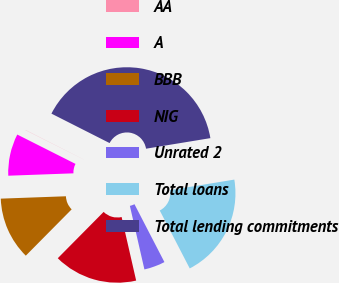Convert chart. <chart><loc_0><loc_0><loc_500><loc_500><pie_chart><fcel>AA<fcel>A<fcel>BBB<fcel>NIG<fcel>Unrated 2<fcel>Total loans<fcel>Total lending commitments<nl><fcel>0.03%<fcel>8.01%<fcel>12.0%<fcel>16.0%<fcel>4.02%<fcel>19.99%<fcel>39.95%<nl></chart> 